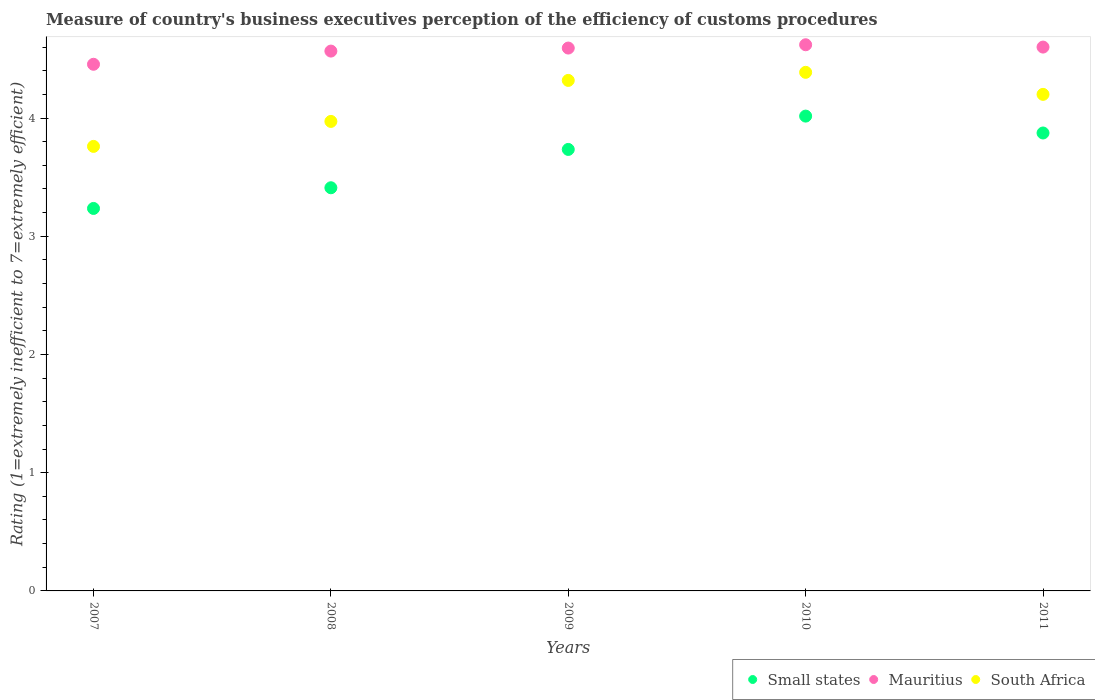Is the number of dotlines equal to the number of legend labels?
Provide a succinct answer. Yes. What is the rating of the efficiency of customs procedure in Mauritius in 2007?
Offer a very short reply. 4.45. Across all years, what is the maximum rating of the efficiency of customs procedure in South Africa?
Your response must be concise. 4.39. Across all years, what is the minimum rating of the efficiency of customs procedure in Small states?
Your answer should be very brief. 3.24. What is the total rating of the efficiency of customs procedure in Mauritius in the graph?
Offer a terse response. 22.83. What is the difference between the rating of the efficiency of customs procedure in South Africa in 2007 and that in 2009?
Give a very brief answer. -0.56. What is the difference between the rating of the efficiency of customs procedure in Small states in 2011 and the rating of the efficiency of customs procedure in South Africa in 2010?
Your answer should be compact. -0.51. What is the average rating of the efficiency of customs procedure in Small states per year?
Provide a succinct answer. 3.65. In the year 2010, what is the difference between the rating of the efficiency of customs procedure in South Africa and rating of the efficiency of customs procedure in Small states?
Ensure brevity in your answer.  0.37. What is the ratio of the rating of the efficiency of customs procedure in South Africa in 2010 to that in 2011?
Provide a short and direct response. 1.04. Is the rating of the efficiency of customs procedure in Mauritius in 2008 less than that in 2011?
Your answer should be compact. Yes. Is the difference between the rating of the efficiency of customs procedure in South Africa in 2007 and 2009 greater than the difference between the rating of the efficiency of customs procedure in Small states in 2007 and 2009?
Your response must be concise. No. What is the difference between the highest and the second highest rating of the efficiency of customs procedure in Small states?
Offer a very short reply. 0.14. What is the difference between the highest and the lowest rating of the efficiency of customs procedure in Mauritius?
Provide a short and direct response. 0.17. Is it the case that in every year, the sum of the rating of the efficiency of customs procedure in Mauritius and rating of the efficiency of customs procedure in South Africa  is greater than the rating of the efficiency of customs procedure in Small states?
Offer a very short reply. Yes. Does the rating of the efficiency of customs procedure in Small states monotonically increase over the years?
Give a very brief answer. No. Is the rating of the efficiency of customs procedure in Mauritius strictly greater than the rating of the efficiency of customs procedure in South Africa over the years?
Give a very brief answer. Yes. Is the rating of the efficiency of customs procedure in South Africa strictly less than the rating of the efficiency of customs procedure in Small states over the years?
Your answer should be compact. No. How many dotlines are there?
Provide a short and direct response. 3. How many years are there in the graph?
Make the answer very short. 5. What is the difference between two consecutive major ticks on the Y-axis?
Provide a succinct answer. 1. Does the graph contain grids?
Give a very brief answer. No. How many legend labels are there?
Provide a short and direct response. 3. How are the legend labels stacked?
Provide a succinct answer. Horizontal. What is the title of the graph?
Give a very brief answer. Measure of country's business executives perception of the efficiency of customs procedures. What is the label or title of the X-axis?
Provide a succinct answer. Years. What is the label or title of the Y-axis?
Keep it short and to the point. Rating (1=extremely inefficient to 7=extremely efficient). What is the Rating (1=extremely inefficient to 7=extremely efficient) in Small states in 2007?
Provide a short and direct response. 3.24. What is the Rating (1=extremely inefficient to 7=extremely efficient) in Mauritius in 2007?
Provide a short and direct response. 4.45. What is the Rating (1=extremely inefficient to 7=extremely efficient) of South Africa in 2007?
Your answer should be very brief. 3.76. What is the Rating (1=extremely inefficient to 7=extremely efficient) in Small states in 2008?
Offer a very short reply. 3.41. What is the Rating (1=extremely inefficient to 7=extremely efficient) of Mauritius in 2008?
Offer a terse response. 4.57. What is the Rating (1=extremely inefficient to 7=extremely efficient) of South Africa in 2008?
Your response must be concise. 3.97. What is the Rating (1=extremely inefficient to 7=extremely efficient) of Small states in 2009?
Your response must be concise. 3.73. What is the Rating (1=extremely inefficient to 7=extremely efficient) in Mauritius in 2009?
Your answer should be compact. 4.59. What is the Rating (1=extremely inefficient to 7=extremely efficient) in South Africa in 2009?
Offer a very short reply. 4.32. What is the Rating (1=extremely inefficient to 7=extremely efficient) of Small states in 2010?
Provide a short and direct response. 4.02. What is the Rating (1=extremely inefficient to 7=extremely efficient) in Mauritius in 2010?
Your answer should be compact. 4.62. What is the Rating (1=extremely inefficient to 7=extremely efficient) of South Africa in 2010?
Provide a short and direct response. 4.39. What is the Rating (1=extremely inefficient to 7=extremely efficient) of Small states in 2011?
Offer a terse response. 3.87. What is the Rating (1=extremely inefficient to 7=extremely efficient) in South Africa in 2011?
Offer a very short reply. 4.2. Across all years, what is the maximum Rating (1=extremely inefficient to 7=extremely efficient) in Small states?
Make the answer very short. 4.02. Across all years, what is the maximum Rating (1=extremely inefficient to 7=extremely efficient) of Mauritius?
Your response must be concise. 4.62. Across all years, what is the maximum Rating (1=extremely inefficient to 7=extremely efficient) in South Africa?
Keep it short and to the point. 4.39. Across all years, what is the minimum Rating (1=extremely inefficient to 7=extremely efficient) in Small states?
Your response must be concise. 3.24. Across all years, what is the minimum Rating (1=extremely inefficient to 7=extremely efficient) of Mauritius?
Provide a succinct answer. 4.45. Across all years, what is the minimum Rating (1=extremely inefficient to 7=extremely efficient) of South Africa?
Give a very brief answer. 3.76. What is the total Rating (1=extremely inefficient to 7=extremely efficient) in Small states in the graph?
Ensure brevity in your answer.  18.27. What is the total Rating (1=extremely inefficient to 7=extremely efficient) of Mauritius in the graph?
Keep it short and to the point. 22.83. What is the total Rating (1=extremely inefficient to 7=extremely efficient) of South Africa in the graph?
Your response must be concise. 20.64. What is the difference between the Rating (1=extremely inefficient to 7=extremely efficient) in Small states in 2007 and that in 2008?
Your answer should be very brief. -0.17. What is the difference between the Rating (1=extremely inefficient to 7=extremely efficient) in Mauritius in 2007 and that in 2008?
Give a very brief answer. -0.11. What is the difference between the Rating (1=extremely inefficient to 7=extremely efficient) in South Africa in 2007 and that in 2008?
Keep it short and to the point. -0.21. What is the difference between the Rating (1=extremely inefficient to 7=extremely efficient) in Small states in 2007 and that in 2009?
Your answer should be compact. -0.5. What is the difference between the Rating (1=extremely inefficient to 7=extremely efficient) of Mauritius in 2007 and that in 2009?
Offer a very short reply. -0.14. What is the difference between the Rating (1=extremely inefficient to 7=extremely efficient) of South Africa in 2007 and that in 2009?
Provide a short and direct response. -0.56. What is the difference between the Rating (1=extremely inefficient to 7=extremely efficient) in Small states in 2007 and that in 2010?
Give a very brief answer. -0.78. What is the difference between the Rating (1=extremely inefficient to 7=extremely efficient) of Mauritius in 2007 and that in 2010?
Your answer should be compact. -0.17. What is the difference between the Rating (1=extremely inefficient to 7=extremely efficient) in South Africa in 2007 and that in 2010?
Your response must be concise. -0.63. What is the difference between the Rating (1=extremely inefficient to 7=extremely efficient) in Small states in 2007 and that in 2011?
Your response must be concise. -0.64. What is the difference between the Rating (1=extremely inefficient to 7=extremely efficient) of Mauritius in 2007 and that in 2011?
Ensure brevity in your answer.  -0.15. What is the difference between the Rating (1=extremely inefficient to 7=extremely efficient) of South Africa in 2007 and that in 2011?
Ensure brevity in your answer.  -0.44. What is the difference between the Rating (1=extremely inefficient to 7=extremely efficient) of Small states in 2008 and that in 2009?
Keep it short and to the point. -0.32. What is the difference between the Rating (1=extremely inefficient to 7=extremely efficient) in Mauritius in 2008 and that in 2009?
Your answer should be compact. -0.03. What is the difference between the Rating (1=extremely inefficient to 7=extremely efficient) in South Africa in 2008 and that in 2009?
Your response must be concise. -0.35. What is the difference between the Rating (1=extremely inefficient to 7=extremely efficient) in Small states in 2008 and that in 2010?
Offer a very short reply. -0.61. What is the difference between the Rating (1=extremely inefficient to 7=extremely efficient) in Mauritius in 2008 and that in 2010?
Your response must be concise. -0.05. What is the difference between the Rating (1=extremely inefficient to 7=extremely efficient) in South Africa in 2008 and that in 2010?
Give a very brief answer. -0.42. What is the difference between the Rating (1=extremely inefficient to 7=extremely efficient) in Small states in 2008 and that in 2011?
Offer a very short reply. -0.46. What is the difference between the Rating (1=extremely inefficient to 7=extremely efficient) in Mauritius in 2008 and that in 2011?
Give a very brief answer. -0.03. What is the difference between the Rating (1=extremely inefficient to 7=extremely efficient) in South Africa in 2008 and that in 2011?
Keep it short and to the point. -0.23. What is the difference between the Rating (1=extremely inefficient to 7=extremely efficient) in Small states in 2009 and that in 2010?
Offer a very short reply. -0.28. What is the difference between the Rating (1=extremely inefficient to 7=extremely efficient) of Mauritius in 2009 and that in 2010?
Your response must be concise. -0.03. What is the difference between the Rating (1=extremely inefficient to 7=extremely efficient) in South Africa in 2009 and that in 2010?
Provide a succinct answer. -0.07. What is the difference between the Rating (1=extremely inefficient to 7=extremely efficient) in Small states in 2009 and that in 2011?
Provide a succinct answer. -0.14. What is the difference between the Rating (1=extremely inefficient to 7=extremely efficient) in Mauritius in 2009 and that in 2011?
Keep it short and to the point. -0.01. What is the difference between the Rating (1=extremely inefficient to 7=extremely efficient) of South Africa in 2009 and that in 2011?
Your answer should be compact. 0.12. What is the difference between the Rating (1=extremely inefficient to 7=extremely efficient) in Small states in 2010 and that in 2011?
Offer a very short reply. 0.14. What is the difference between the Rating (1=extremely inefficient to 7=extremely efficient) in Mauritius in 2010 and that in 2011?
Make the answer very short. 0.02. What is the difference between the Rating (1=extremely inefficient to 7=extremely efficient) in South Africa in 2010 and that in 2011?
Provide a short and direct response. 0.19. What is the difference between the Rating (1=extremely inefficient to 7=extremely efficient) of Small states in 2007 and the Rating (1=extremely inefficient to 7=extremely efficient) of Mauritius in 2008?
Your answer should be very brief. -1.33. What is the difference between the Rating (1=extremely inefficient to 7=extremely efficient) in Small states in 2007 and the Rating (1=extremely inefficient to 7=extremely efficient) in South Africa in 2008?
Provide a succinct answer. -0.74. What is the difference between the Rating (1=extremely inefficient to 7=extremely efficient) in Mauritius in 2007 and the Rating (1=extremely inefficient to 7=extremely efficient) in South Africa in 2008?
Your answer should be compact. 0.48. What is the difference between the Rating (1=extremely inefficient to 7=extremely efficient) in Small states in 2007 and the Rating (1=extremely inefficient to 7=extremely efficient) in Mauritius in 2009?
Your response must be concise. -1.36. What is the difference between the Rating (1=extremely inefficient to 7=extremely efficient) of Small states in 2007 and the Rating (1=extremely inefficient to 7=extremely efficient) of South Africa in 2009?
Your answer should be compact. -1.08. What is the difference between the Rating (1=extremely inefficient to 7=extremely efficient) in Mauritius in 2007 and the Rating (1=extremely inefficient to 7=extremely efficient) in South Africa in 2009?
Your response must be concise. 0.14. What is the difference between the Rating (1=extremely inefficient to 7=extremely efficient) in Small states in 2007 and the Rating (1=extremely inefficient to 7=extremely efficient) in Mauritius in 2010?
Give a very brief answer. -1.38. What is the difference between the Rating (1=extremely inefficient to 7=extremely efficient) of Small states in 2007 and the Rating (1=extremely inefficient to 7=extremely efficient) of South Africa in 2010?
Offer a terse response. -1.15. What is the difference between the Rating (1=extremely inefficient to 7=extremely efficient) of Mauritius in 2007 and the Rating (1=extremely inefficient to 7=extremely efficient) of South Africa in 2010?
Provide a short and direct response. 0.07. What is the difference between the Rating (1=extremely inefficient to 7=extremely efficient) of Small states in 2007 and the Rating (1=extremely inefficient to 7=extremely efficient) of Mauritius in 2011?
Provide a short and direct response. -1.36. What is the difference between the Rating (1=extremely inefficient to 7=extremely efficient) in Small states in 2007 and the Rating (1=extremely inefficient to 7=extremely efficient) in South Africa in 2011?
Make the answer very short. -0.96. What is the difference between the Rating (1=extremely inefficient to 7=extremely efficient) in Mauritius in 2007 and the Rating (1=extremely inefficient to 7=extremely efficient) in South Africa in 2011?
Ensure brevity in your answer.  0.25. What is the difference between the Rating (1=extremely inefficient to 7=extremely efficient) in Small states in 2008 and the Rating (1=extremely inefficient to 7=extremely efficient) in Mauritius in 2009?
Your answer should be compact. -1.18. What is the difference between the Rating (1=extremely inefficient to 7=extremely efficient) of Small states in 2008 and the Rating (1=extremely inefficient to 7=extremely efficient) of South Africa in 2009?
Offer a terse response. -0.91. What is the difference between the Rating (1=extremely inefficient to 7=extremely efficient) in Mauritius in 2008 and the Rating (1=extremely inefficient to 7=extremely efficient) in South Africa in 2009?
Your response must be concise. 0.25. What is the difference between the Rating (1=extremely inefficient to 7=extremely efficient) in Small states in 2008 and the Rating (1=extremely inefficient to 7=extremely efficient) in Mauritius in 2010?
Your answer should be very brief. -1.21. What is the difference between the Rating (1=extremely inefficient to 7=extremely efficient) of Small states in 2008 and the Rating (1=extremely inefficient to 7=extremely efficient) of South Africa in 2010?
Your response must be concise. -0.98. What is the difference between the Rating (1=extremely inefficient to 7=extremely efficient) of Mauritius in 2008 and the Rating (1=extremely inefficient to 7=extremely efficient) of South Africa in 2010?
Provide a succinct answer. 0.18. What is the difference between the Rating (1=extremely inefficient to 7=extremely efficient) in Small states in 2008 and the Rating (1=extremely inefficient to 7=extremely efficient) in Mauritius in 2011?
Your answer should be compact. -1.19. What is the difference between the Rating (1=extremely inefficient to 7=extremely efficient) of Small states in 2008 and the Rating (1=extremely inefficient to 7=extremely efficient) of South Africa in 2011?
Make the answer very short. -0.79. What is the difference between the Rating (1=extremely inefficient to 7=extremely efficient) of Mauritius in 2008 and the Rating (1=extremely inefficient to 7=extremely efficient) of South Africa in 2011?
Offer a terse response. 0.37. What is the difference between the Rating (1=extremely inefficient to 7=extremely efficient) in Small states in 2009 and the Rating (1=extremely inefficient to 7=extremely efficient) in Mauritius in 2010?
Offer a very short reply. -0.89. What is the difference between the Rating (1=extremely inefficient to 7=extremely efficient) in Small states in 2009 and the Rating (1=extremely inefficient to 7=extremely efficient) in South Africa in 2010?
Provide a succinct answer. -0.65. What is the difference between the Rating (1=extremely inefficient to 7=extremely efficient) in Mauritius in 2009 and the Rating (1=extremely inefficient to 7=extremely efficient) in South Africa in 2010?
Provide a short and direct response. 0.21. What is the difference between the Rating (1=extremely inefficient to 7=extremely efficient) of Small states in 2009 and the Rating (1=extremely inefficient to 7=extremely efficient) of Mauritius in 2011?
Offer a very short reply. -0.87. What is the difference between the Rating (1=extremely inefficient to 7=extremely efficient) in Small states in 2009 and the Rating (1=extremely inefficient to 7=extremely efficient) in South Africa in 2011?
Provide a short and direct response. -0.47. What is the difference between the Rating (1=extremely inefficient to 7=extremely efficient) of Mauritius in 2009 and the Rating (1=extremely inefficient to 7=extremely efficient) of South Africa in 2011?
Your response must be concise. 0.39. What is the difference between the Rating (1=extremely inefficient to 7=extremely efficient) in Small states in 2010 and the Rating (1=extremely inefficient to 7=extremely efficient) in Mauritius in 2011?
Your answer should be compact. -0.58. What is the difference between the Rating (1=extremely inefficient to 7=extremely efficient) of Small states in 2010 and the Rating (1=extremely inefficient to 7=extremely efficient) of South Africa in 2011?
Your answer should be very brief. -0.18. What is the difference between the Rating (1=extremely inefficient to 7=extremely efficient) in Mauritius in 2010 and the Rating (1=extremely inefficient to 7=extremely efficient) in South Africa in 2011?
Provide a short and direct response. 0.42. What is the average Rating (1=extremely inefficient to 7=extremely efficient) in Small states per year?
Offer a very short reply. 3.65. What is the average Rating (1=extremely inefficient to 7=extremely efficient) of Mauritius per year?
Provide a short and direct response. 4.57. What is the average Rating (1=extremely inefficient to 7=extremely efficient) of South Africa per year?
Your response must be concise. 4.13. In the year 2007, what is the difference between the Rating (1=extremely inefficient to 7=extremely efficient) of Small states and Rating (1=extremely inefficient to 7=extremely efficient) of Mauritius?
Your answer should be compact. -1.22. In the year 2007, what is the difference between the Rating (1=extremely inefficient to 7=extremely efficient) of Small states and Rating (1=extremely inefficient to 7=extremely efficient) of South Africa?
Give a very brief answer. -0.52. In the year 2007, what is the difference between the Rating (1=extremely inefficient to 7=extremely efficient) in Mauritius and Rating (1=extremely inefficient to 7=extremely efficient) in South Africa?
Provide a succinct answer. 0.69. In the year 2008, what is the difference between the Rating (1=extremely inefficient to 7=extremely efficient) of Small states and Rating (1=extremely inefficient to 7=extremely efficient) of Mauritius?
Provide a succinct answer. -1.16. In the year 2008, what is the difference between the Rating (1=extremely inefficient to 7=extremely efficient) in Small states and Rating (1=extremely inefficient to 7=extremely efficient) in South Africa?
Offer a terse response. -0.56. In the year 2008, what is the difference between the Rating (1=extremely inefficient to 7=extremely efficient) in Mauritius and Rating (1=extremely inefficient to 7=extremely efficient) in South Africa?
Your answer should be compact. 0.59. In the year 2009, what is the difference between the Rating (1=extremely inefficient to 7=extremely efficient) of Small states and Rating (1=extremely inefficient to 7=extremely efficient) of Mauritius?
Provide a short and direct response. -0.86. In the year 2009, what is the difference between the Rating (1=extremely inefficient to 7=extremely efficient) of Small states and Rating (1=extremely inefficient to 7=extremely efficient) of South Africa?
Keep it short and to the point. -0.58. In the year 2009, what is the difference between the Rating (1=extremely inefficient to 7=extremely efficient) in Mauritius and Rating (1=extremely inefficient to 7=extremely efficient) in South Africa?
Offer a terse response. 0.27. In the year 2010, what is the difference between the Rating (1=extremely inefficient to 7=extremely efficient) in Small states and Rating (1=extremely inefficient to 7=extremely efficient) in Mauritius?
Give a very brief answer. -0.6. In the year 2010, what is the difference between the Rating (1=extremely inefficient to 7=extremely efficient) of Small states and Rating (1=extremely inefficient to 7=extremely efficient) of South Africa?
Keep it short and to the point. -0.37. In the year 2010, what is the difference between the Rating (1=extremely inefficient to 7=extremely efficient) of Mauritius and Rating (1=extremely inefficient to 7=extremely efficient) of South Africa?
Provide a succinct answer. 0.23. In the year 2011, what is the difference between the Rating (1=extremely inefficient to 7=extremely efficient) of Small states and Rating (1=extremely inefficient to 7=extremely efficient) of Mauritius?
Offer a very short reply. -0.73. In the year 2011, what is the difference between the Rating (1=extremely inefficient to 7=extremely efficient) of Small states and Rating (1=extremely inefficient to 7=extremely efficient) of South Africa?
Ensure brevity in your answer.  -0.33. What is the ratio of the Rating (1=extremely inefficient to 7=extremely efficient) of Small states in 2007 to that in 2008?
Give a very brief answer. 0.95. What is the ratio of the Rating (1=extremely inefficient to 7=extremely efficient) of Mauritius in 2007 to that in 2008?
Give a very brief answer. 0.98. What is the ratio of the Rating (1=extremely inefficient to 7=extremely efficient) of South Africa in 2007 to that in 2008?
Give a very brief answer. 0.95. What is the ratio of the Rating (1=extremely inefficient to 7=extremely efficient) in Small states in 2007 to that in 2009?
Make the answer very short. 0.87. What is the ratio of the Rating (1=extremely inefficient to 7=extremely efficient) in Mauritius in 2007 to that in 2009?
Provide a succinct answer. 0.97. What is the ratio of the Rating (1=extremely inefficient to 7=extremely efficient) in South Africa in 2007 to that in 2009?
Make the answer very short. 0.87. What is the ratio of the Rating (1=extremely inefficient to 7=extremely efficient) in Small states in 2007 to that in 2010?
Provide a succinct answer. 0.81. What is the ratio of the Rating (1=extremely inefficient to 7=extremely efficient) of South Africa in 2007 to that in 2010?
Provide a short and direct response. 0.86. What is the ratio of the Rating (1=extremely inefficient to 7=extremely efficient) of Small states in 2007 to that in 2011?
Offer a terse response. 0.84. What is the ratio of the Rating (1=extremely inefficient to 7=extremely efficient) of Mauritius in 2007 to that in 2011?
Give a very brief answer. 0.97. What is the ratio of the Rating (1=extremely inefficient to 7=extremely efficient) in South Africa in 2007 to that in 2011?
Provide a short and direct response. 0.9. What is the ratio of the Rating (1=extremely inefficient to 7=extremely efficient) in Small states in 2008 to that in 2009?
Your answer should be very brief. 0.91. What is the ratio of the Rating (1=extremely inefficient to 7=extremely efficient) in South Africa in 2008 to that in 2009?
Keep it short and to the point. 0.92. What is the ratio of the Rating (1=extremely inefficient to 7=extremely efficient) of Small states in 2008 to that in 2010?
Your answer should be compact. 0.85. What is the ratio of the Rating (1=extremely inefficient to 7=extremely efficient) of Mauritius in 2008 to that in 2010?
Provide a succinct answer. 0.99. What is the ratio of the Rating (1=extremely inefficient to 7=extremely efficient) of South Africa in 2008 to that in 2010?
Provide a succinct answer. 0.91. What is the ratio of the Rating (1=extremely inefficient to 7=extremely efficient) of Small states in 2008 to that in 2011?
Your answer should be very brief. 0.88. What is the ratio of the Rating (1=extremely inefficient to 7=extremely efficient) of South Africa in 2008 to that in 2011?
Give a very brief answer. 0.95. What is the ratio of the Rating (1=extremely inefficient to 7=extremely efficient) in Small states in 2009 to that in 2010?
Your answer should be very brief. 0.93. What is the ratio of the Rating (1=extremely inefficient to 7=extremely efficient) of South Africa in 2009 to that in 2010?
Ensure brevity in your answer.  0.98. What is the ratio of the Rating (1=extremely inefficient to 7=extremely efficient) in Small states in 2009 to that in 2011?
Your answer should be very brief. 0.96. What is the ratio of the Rating (1=extremely inefficient to 7=extremely efficient) in Mauritius in 2009 to that in 2011?
Your answer should be compact. 1. What is the ratio of the Rating (1=extremely inefficient to 7=extremely efficient) in South Africa in 2009 to that in 2011?
Offer a very short reply. 1.03. What is the ratio of the Rating (1=extremely inefficient to 7=extremely efficient) in Small states in 2010 to that in 2011?
Your response must be concise. 1.04. What is the ratio of the Rating (1=extremely inefficient to 7=extremely efficient) in Mauritius in 2010 to that in 2011?
Your response must be concise. 1. What is the ratio of the Rating (1=extremely inefficient to 7=extremely efficient) in South Africa in 2010 to that in 2011?
Your answer should be compact. 1.04. What is the difference between the highest and the second highest Rating (1=extremely inefficient to 7=extremely efficient) in Small states?
Provide a short and direct response. 0.14. What is the difference between the highest and the second highest Rating (1=extremely inefficient to 7=extremely efficient) of Mauritius?
Make the answer very short. 0.02. What is the difference between the highest and the second highest Rating (1=extremely inefficient to 7=extremely efficient) of South Africa?
Offer a terse response. 0.07. What is the difference between the highest and the lowest Rating (1=extremely inefficient to 7=extremely efficient) in Small states?
Your response must be concise. 0.78. What is the difference between the highest and the lowest Rating (1=extremely inefficient to 7=extremely efficient) of Mauritius?
Your response must be concise. 0.17. What is the difference between the highest and the lowest Rating (1=extremely inefficient to 7=extremely efficient) in South Africa?
Offer a very short reply. 0.63. 